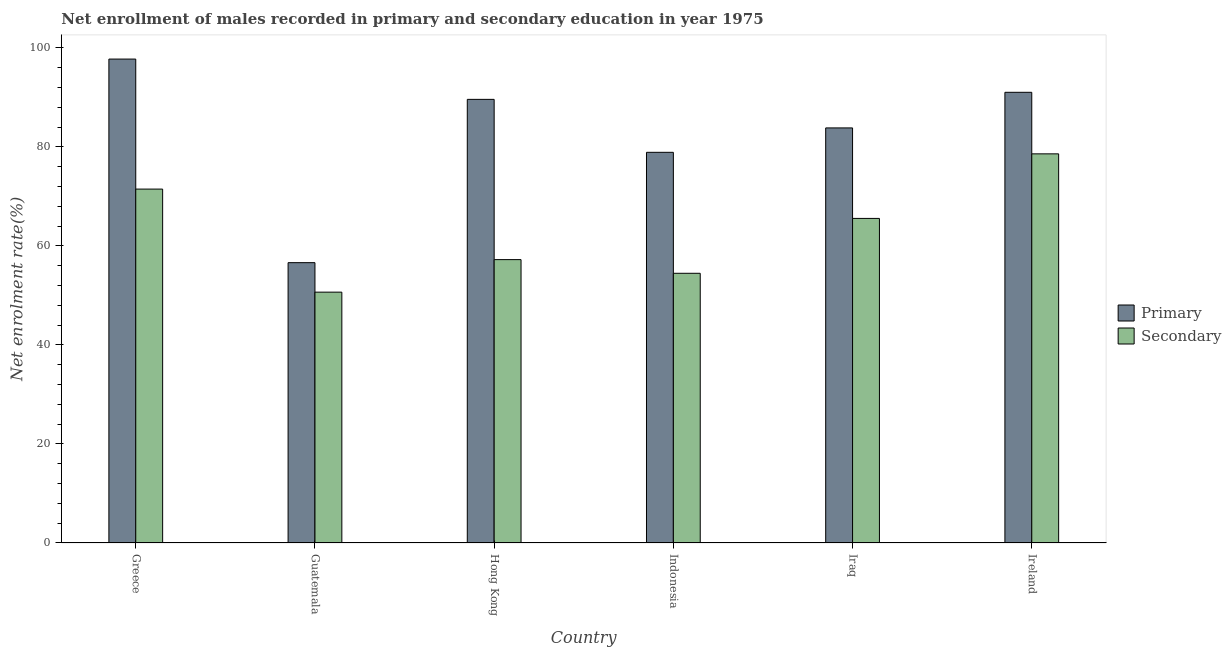How many different coloured bars are there?
Offer a terse response. 2. Are the number of bars on each tick of the X-axis equal?
Your answer should be compact. Yes. How many bars are there on the 1st tick from the right?
Ensure brevity in your answer.  2. What is the label of the 2nd group of bars from the left?
Your answer should be very brief. Guatemala. What is the enrollment rate in secondary education in Hong Kong?
Your response must be concise. 57.23. Across all countries, what is the maximum enrollment rate in primary education?
Provide a succinct answer. 97.73. Across all countries, what is the minimum enrollment rate in secondary education?
Provide a short and direct response. 50.66. In which country was the enrollment rate in primary education minimum?
Keep it short and to the point. Guatemala. What is the total enrollment rate in secondary education in the graph?
Keep it short and to the point. 377.97. What is the difference between the enrollment rate in primary education in Greece and that in Hong Kong?
Offer a very short reply. 8.14. What is the difference between the enrollment rate in primary education in Hong Kong and the enrollment rate in secondary education in Guatemala?
Offer a terse response. 38.93. What is the average enrollment rate in primary education per country?
Offer a terse response. 82.95. What is the difference between the enrollment rate in primary education and enrollment rate in secondary education in Greece?
Keep it short and to the point. 26.26. In how many countries, is the enrollment rate in secondary education greater than 12 %?
Give a very brief answer. 6. What is the ratio of the enrollment rate in secondary education in Guatemala to that in Indonesia?
Provide a succinct answer. 0.93. Is the enrollment rate in secondary education in Hong Kong less than that in Indonesia?
Offer a very short reply. No. Is the difference between the enrollment rate in primary education in Iraq and Ireland greater than the difference between the enrollment rate in secondary education in Iraq and Ireland?
Give a very brief answer. Yes. What is the difference between the highest and the second highest enrollment rate in primary education?
Offer a very short reply. 6.71. What is the difference between the highest and the lowest enrollment rate in secondary education?
Offer a terse response. 27.93. In how many countries, is the enrollment rate in primary education greater than the average enrollment rate in primary education taken over all countries?
Ensure brevity in your answer.  4. What does the 1st bar from the left in Guatemala represents?
Keep it short and to the point. Primary. What does the 1st bar from the right in Ireland represents?
Give a very brief answer. Secondary. How many bars are there?
Ensure brevity in your answer.  12. Are all the bars in the graph horizontal?
Your answer should be compact. No. How many countries are there in the graph?
Your response must be concise. 6. What is the difference between two consecutive major ticks on the Y-axis?
Your answer should be very brief. 20. What is the title of the graph?
Offer a very short reply. Net enrollment of males recorded in primary and secondary education in year 1975. What is the label or title of the X-axis?
Offer a terse response. Country. What is the label or title of the Y-axis?
Your answer should be compact. Net enrolment rate(%). What is the Net enrolment rate(%) in Primary in Greece?
Give a very brief answer. 97.73. What is the Net enrolment rate(%) of Secondary in Greece?
Your answer should be compact. 71.47. What is the Net enrolment rate(%) of Primary in Guatemala?
Make the answer very short. 56.61. What is the Net enrolment rate(%) of Secondary in Guatemala?
Your response must be concise. 50.66. What is the Net enrolment rate(%) of Primary in Hong Kong?
Provide a succinct answer. 89.59. What is the Net enrolment rate(%) of Secondary in Hong Kong?
Give a very brief answer. 57.23. What is the Net enrolment rate(%) of Primary in Indonesia?
Give a very brief answer. 78.9. What is the Net enrolment rate(%) of Secondary in Indonesia?
Give a very brief answer. 54.47. What is the Net enrolment rate(%) in Primary in Iraq?
Offer a very short reply. 83.83. What is the Net enrolment rate(%) of Secondary in Iraq?
Your answer should be compact. 65.55. What is the Net enrolment rate(%) of Primary in Ireland?
Ensure brevity in your answer.  91.02. What is the Net enrolment rate(%) of Secondary in Ireland?
Your answer should be compact. 78.59. Across all countries, what is the maximum Net enrolment rate(%) in Primary?
Offer a terse response. 97.73. Across all countries, what is the maximum Net enrolment rate(%) of Secondary?
Your answer should be very brief. 78.59. Across all countries, what is the minimum Net enrolment rate(%) of Primary?
Make the answer very short. 56.61. Across all countries, what is the minimum Net enrolment rate(%) of Secondary?
Make the answer very short. 50.66. What is the total Net enrolment rate(%) in Primary in the graph?
Ensure brevity in your answer.  497.68. What is the total Net enrolment rate(%) of Secondary in the graph?
Give a very brief answer. 377.97. What is the difference between the Net enrolment rate(%) of Primary in Greece and that in Guatemala?
Provide a short and direct response. 41.12. What is the difference between the Net enrolment rate(%) in Secondary in Greece and that in Guatemala?
Make the answer very short. 20.82. What is the difference between the Net enrolment rate(%) in Primary in Greece and that in Hong Kong?
Your answer should be compact. 8.14. What is the difference between the Net enrolment rate(%) of Secondary in Greece and that in Hong Kong?
Provide a short and direct response. 14.25. What is the difference between the Net enrolment rate(%) in Primary in Greece and that in Indonesia?
Offer a very short reply. 18.83. What is the difference between the Net enrolment rate(%) in Secondary in Greece and that in Indonesia?
Your response must be concise. 17.01. What is the difference between the Net enrolment rate(%) of Primary in Greece and that in Iraq?
Offer a very short reply. 13.9. What is the difference between the Net enrolment rate(%) of Secondary in Greece and that in Iraq?
Your response must be concise. 5.92. What is the difference between the Net enrolment rate(%) in Primary in Greece and that in Ireland?
Offer a terse response. 6.71. What is the difference between the Net enrolment rate(%) of Secondary in Greece and that in Ireland?
Keep it short and to the point. -7.11. What is the difference between the Net enrolment rate(%) of Primary in Guatemala and that in Hong Kong?
Offer a very short reply. -32.98. What is the difference between the Net enrolment rate(%) in Secondary in Guatemala and that in Hong Kong?
Offer a terse response. -6.57. What is the difference between the Net enrolment rate(%) of Primary in Guatemala and that in Indonesia?
Your answer should be very brief. -22.28. What is the difference between the Net enrolment rate(%) in Secondary in Guatemala and that in Indonesia?
Keep it short and to the point. -3.81. What is the difference between the Net enrolment rate(%) in Primary in Guatemala and that in Iraq?
Your response must be concise. -27.21. What is the difference between the Net enrolment rate(%) in Secondary in Guatemala and that in Iraq?
Your answer should be compact. -14.89. What is the difference between the Net enrolment rate(%) of Primary in Guatemala and that in Ireland?
Your answer should be compact. -34.4. What is the difference between the Net enrolment rate(%) in Secondary in Guatemala and that in Ireland?
Offer a terse response. -27.93. What is the difference between the Net enrolment rate(%) of Primary in Hong Kong and that in Indonesia?
Offer a very short reply. 10.69. What is the difference between the Net enrolment rate(%) of Secondary in Hong Kong and that in Indonesia?
Offer a terse response. 2.76. What is the difference between the Net enrolment rate(%) in Primary in Hong Kong and that in Iraq?
Ensure brevity in your answer.  5.76. What is the difference between the Net enrolment rate(%) of Secondary in Hong Kong and that in Iraq?
Your response must be concise. -8.32. What is the difference between the Net enrolment rate(%) in Primary in Hong Kong and that in Ireland?
Provide a short and direct response. -1.43. What is the difference between the Net enrolment rate(%) in Secondary in Hong Kong and that in Ireland?
Your answer should be compact. -21.36. What is the difference between the Net enrolment rate(%) of Primary in Indonesia and that in Iraq?
Provide a succinct answer. -4.93. What is the difference between the Net enrolment rate(%) in Secondary in Indonesia and that in Iraq?
Offer a very short reply. -11.08. What is the difference between the Net enrolment rate(%) in Primary in Indonesia and that in Ireland?
Provide a short and direct response. -12.12. What is the difference between the Net enrolment rate(%) in Secondary in Indonesia and that in Ireland?
Make the answer very short. -24.12. What is the difference between the Net enrolment rate(%) in Primary in Iraq and that in Ireland?
Keep it short and to the point. -7.19. What is the difference between the Net enrolment rate(%) in Secondary in Iraq and that in Ireland?
Ensure brevity in your answer.  -13.04. What is the difference between the Net enrolment rate(%) in Primary in Greece and the Net enrolment rate(%) in Secondary in Guatemala?
Your answer should be very brief. 47.07. What is the difference between the Net enrolment rate(%) in Primary in Greece and the Net enrolment rate(%) in Secondary in Hong Kong?
Keep it short and to the point. 40.5. What is the difference between the Net enrolment rate(%) of Primary in Greece and the Net enrolment rate(%) of Secondary in Indonesia?
Offer a terse response. 43.26. What is the difference between the Net enrolment rate(%) of Primary in Greece and the Net enrolment rate(%) of Secondary in Iraq?
Provide a succinct answer. 32.18. What is the difference between the Net enrolment rate(%) in Primary in Greece and the Net enrolment rate(%) in Secondary in Ireland?
Ensure brevity in your answer.  19.14. What is the difference between the Net enrolment rate(%) of Primary in Guatemala and the Net enrolment rate(%) of Secondary in Hong Kong?
Provide a short and direct response. -0.61. What is the difference between the Net enrolment rate(%) in Primary in Guatemala and the Net enrolment rate(%) in Secondary in Indonesia?
Provide a short and direct response. 2.15. What is the difference between the Net enrolment rate(%) of Primary in Guatemala and the Net enrolment rate(%) of Secondary in Iraq?
Your answer should be compact. -8.94. What is the difference between the Net enrolment rate(%) in Primary in Guatemala and the Net enrolment rate(%) in Secondary in Ireland?
Ensure brevity in your answer.  -21.97. What is the difference between the Net enrolment rate(%) in Primary in Hong Kong and the Net enrolment rate(%) in Secondary in Indonesia?
Offer a very short reply. 35.12. What is the difference between the Net enrolment rate(%) in Primary in Hong Kong and the Net enrolment rate(%) in Secondary in Iraq?
Offer a very short reply. 24.04. What is the difference between the Net enrolment rate(%) of Primary in Hong Kong and the Net enrolment rate(%) of Secondary in Ireland?
Offer a terse response. 11. What is the difference between the Net enrolment rate(%) of Primary in Indonesia and the Net enrolment rate(%) of Secondary in Iraq?
Provide a succinct answer. 13.35. What is the difference between the Net enrolment rate(%) of Primary in Indonesia and the Net enrolment rate(%) of Secondary in Ireland?
Offer a very short reply. 0.31. What is the difference between the Net enrolment rate(%) in Primary in Iraq and the Net enrolment rate(%) in Secondary in Ireland?
Your answer should be very brief. 5.24. What is the average Net enrolment rate(%) in Primary per country?
Offer a very short reply. 82.95. What is the average Net enrolment rate(%) of Secondary per country?
Ensure brevity in your answer.  63. What is the difference between the Net enrolment rate(%) of Primary and Net enrolment rate(%) of Secondary in Greece?
Keep it short and to the point. 26.26. What is the difference between the Net enrolment rate(%) of Primary and Net enrolment rate(%) of Secondary in Guatemala?
Your response must be concise. 5.96. What is the difference between the Net enrolment rate(%) in Primary and Net enrolment rate(%) in Secondary in Hong Kong?
Your answer should be compact. 32.36. What is the difference between the Net enrolment rate(%) in Primary and Net enrolment rate(%) in Secondary in Indonesia?
Give a very brief answer. 24.43. What is the difference between the Net enrolment rate(%) in Primary and Net enrolment rate(%) in Secondary in Iraq?
Provide a short and direct response. 18.28. What is the difference between the Net enrolment rate(%) of Primary and Net enrolment rate(%) of Secondary in Ireland?
Ensure brevity in your answer.  12.43. What is the ratio of the Net enrolment rate(%) in Primary in Greece to that in Guatemala?
Your answer should be compact. 1.73. What is the ratio of the Net enrolment rate(%) in Secondary in Greece to that in Guatemala?
Keep it short and to the point. 1.41. What is the ratio of the Net enrolment rate(%) of Primary in Greece to that in Hong Kong?
Keep it short and to the point. 1.09. What is the ratio of the Net enrolment rate(%) in Secondary in Greece to that in Hong Kong?
Offer a terse response. 1.25. What is the ratio of the Net enrolment rate(%) of Primary in Greece to that in Indonesia?
Your answer should be compact. 1.24. What is the ratio of the Net enrolment rate(%) in Secondary in Greece to that in Indonesia?
Your answer should be compact. 1.31. What is the ratio of the Net enrolment rate(%) in Primary in Greece to that in Iraq?
Offer a terse response. 1.17. What is the ratio of the Net enrolment rate(%) in Secondary in Greece to that in Iraq?
Provide a short and direct response. 1.09. What is the ratio of the Net enrolment rate(%) in Primary in Greece to that in Ireland?
Make the answer very short. 1.07. What is the ratio of the Net enrolment rate(%) of Secondary in Greece to that in Ireland?
Offer a terse response. 0.91. What is the ratio of the Net enrolment rate(%) of Primary in Guatemala to that in Hong Kong?
Provide a short and direct response. 0.63. What is the ratio of the Net enrolment rate(%) of Secondary in Guatemala to that in Hong Kong?
Make the answer very short. 0.89. What is the ratio of the Net enrolment rate(%) in Primary in Guatemala to that in Indonesia?
Make the answer very short. 0.72. What is the ratio of the Net enrolment rate(%) in Secondary in Guatemala to that in Indonesia?
Provide a succinct answer. 0.93. What is the ratio of the Net enrolment rate(%) of Primary in Guatemala to that in Iraq?
Keep it short and to the point. 0.68. What is the ratio of the Net enrolment rate(%) of Secondary in Guatemala to that in Iraq?
Give a very brief answer. 0.77. What is the ratio of the Net enrolment rate(%) of Primary in Guatemala to that in Ireland?
Provide a short and direct response. 0.62. What is the ratio of the Net enrolment rate(%) of Secondary in Guatemala to that in Ireland?
Ensure brevity in your answer.  0.64. What is the ratio of the Net enrolment rate(%) of Primary in Hong Kong to that in Indonesia?
Your answer should be very brief. 1.14. What is the ratio of the Net enrolment rate(%) of Secondary in Hong Kong to that in Indonesia?
Give a very brief answer. 1.05. What is the ratio of the Net enrolment rate(%) in Primary in Hong Kong to that in Iraq?
Your response must be concise. 1.07. What is the ratio of the Net enrolment rate(%) in Secondary in Hong Kong to that in Iraq?
Your response must be concise. 0.87. What is the ratio of the Net enrolment rate(%) of Primary in Hong Kong to that in Ireland?
Give a very brief answer. 0.98. What is the ratio of the Net enrolment rate(%) of Secondary in Hong Kong to that in Ireland?
Make the answer very short. 0.73. What is the ratio of the Net enrolment rate(%) of Secondary in Indonesia to that in Iraq?
Offer a terse response. 0.83. What is the ratio of the Net enrolment rate(%) of Primary in Indonesia to that in Ireland?
Offer a terse response. 0.87. What is the ratio of the Net enrolment rate(%) of Secondary in Indonesia to that in Ireland?
Give a very brief answer. 0.69. What is the ratio of the Net enrolment rate(%) of Primary in Iraq to that in Ireland?
Keep it short and to the point. 0.92. What is the ratio of the Net enrolment rate(%) in Secondary in Iraq to that in Ireland?
Provide a short and direct response. 0.83. What is the difference between the highest and the second highest Net enrolment rate(%) in Primary?
Your answer should be compact. 6.71. What is the difference between the highest and the second highest Net enrolment rate(%) in Secondary?
Offer a terse response. 7.11. What is the difference between the highest and the lowest Net enrolment rate(%) of Primary?
Give a very brief answer. 41.12. What is the difference between the highest and the lowest Net enrolment rate(%) in Secondary?
Make the answer very short. 27.93. 